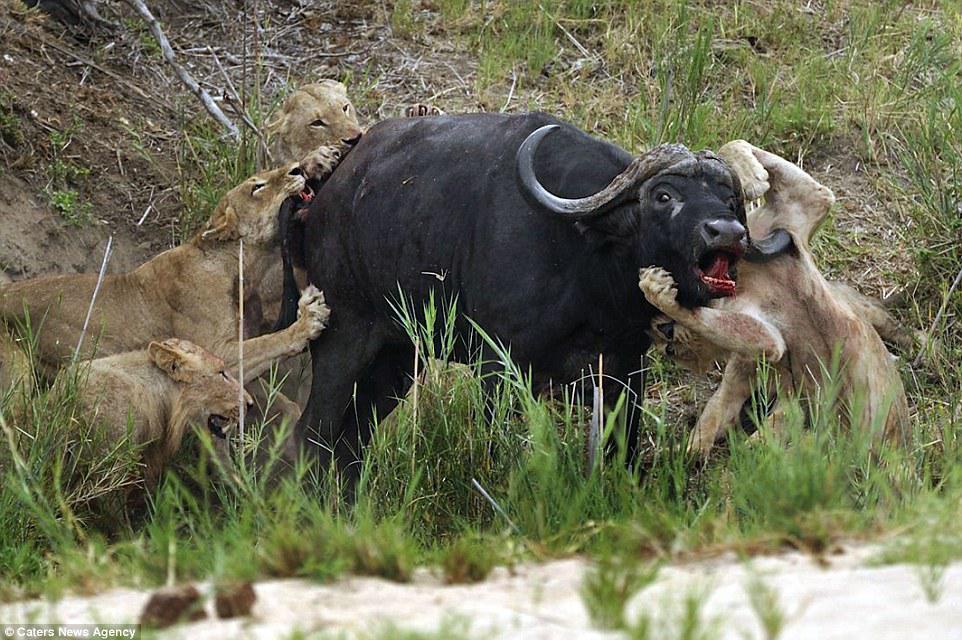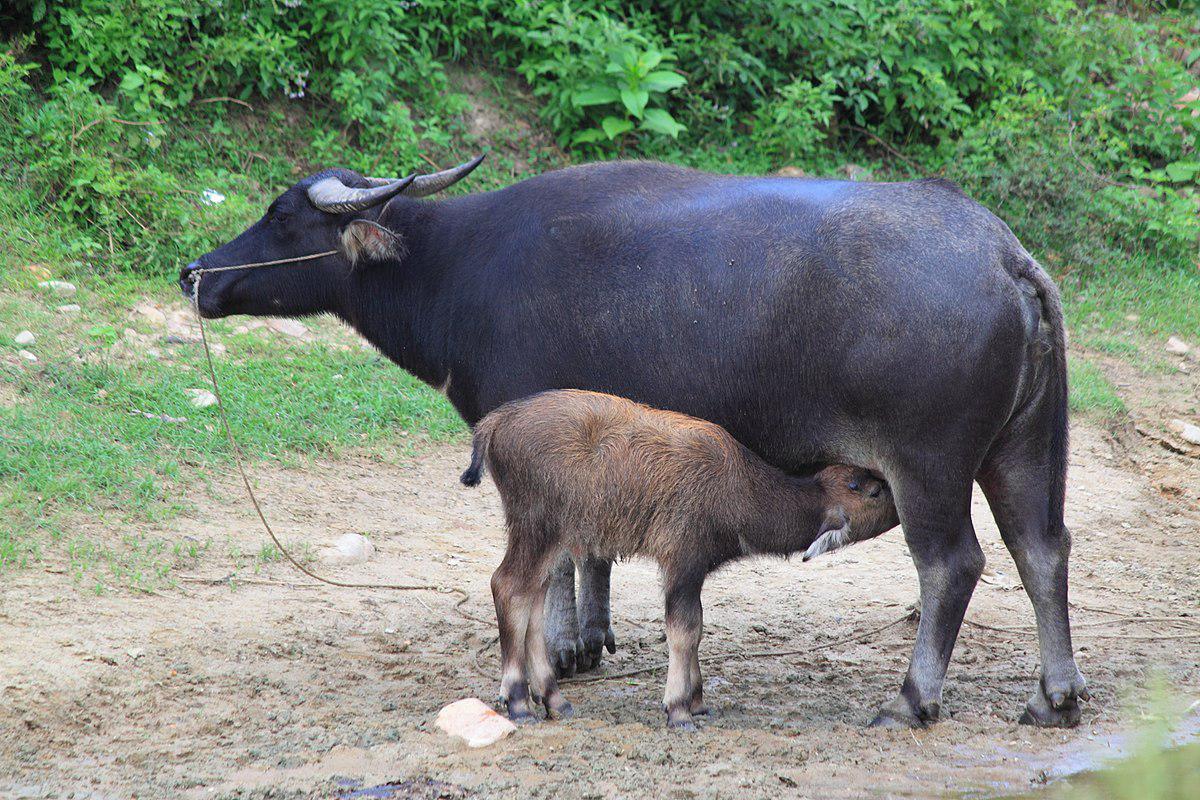The first image is the image on the left, the second image is the image on the right. Given the left and right images, does the statement "Both images show men behind oxen pulling plows." hold true? Answer yes or no. No. 